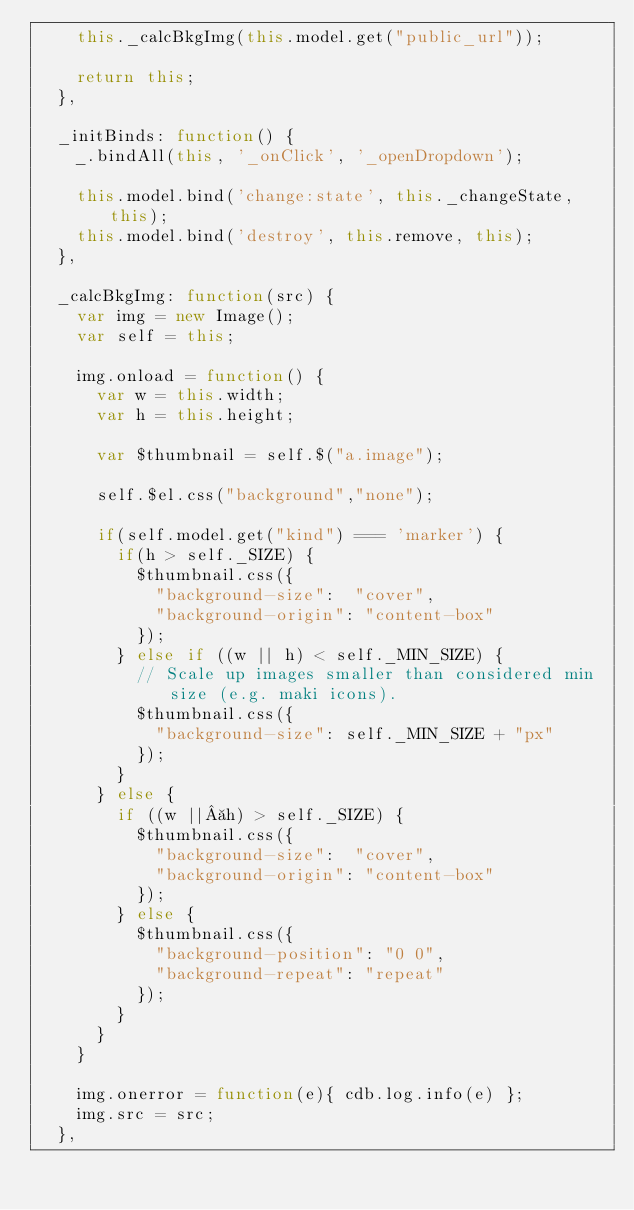<code> <loc_0><loc_0><loc_500><loc_500><_JavaScript_>    this._calcBkgImg(this.model.get("public_url"));

    return this;
  },

  _initBinds: function() {
    _.bindAll(this, '_onClick', '_openDropdown');

    this.model.bind('change:state', this._changeState, this);
    this.model.bind('destroy', this.remove, this);
  },

  _calcBkgImg: function(src) {
    var img = new Image();
    var self = this;

    img.onload = function() {
      var w = this.width;
      var h = this.height;

      var $thumbnail = self.$("a.image");

      self.$el.css("background","none");

      if(self.model.get("kind") === 'marker') {
        if(h > self._SIZE) {
          $thumbnail.css({
            "background-size":  "cover",
            "background-origin": "content-box"
          });
        } else if ((w || h) < self._MIN_SIZE) {
          // Scale up images smaller than considered min size (e.g. maki icons).
          $thumbnail.css({
            "background-size": self._MIN_SIZE + "px"
          });
        }
      } else {
        if ((w || h) > self._SIZE) {
          $thumbnail.css({
            "background-size":  "cover",
            "background-origin": "content-box"
          });
        } else {
          $thumbnail.css({
            "background-position": "0 0",
            "background-repeat": "repeat"
          });
        }
      }
    }

    img.onerror = function(e){ cdb.log.info(e) };
    img.src = src;
  },
</code> 